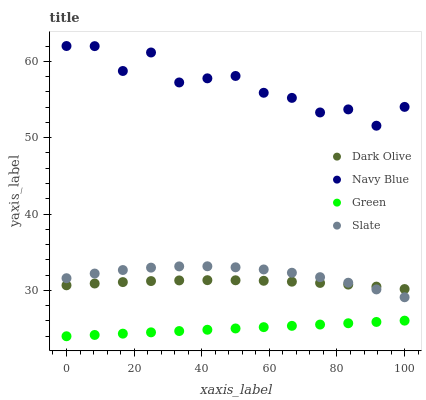Does Green have the minimum area under the curve?
Answer yes or no. Yes. Does Navy Blue have the maximum area under the curve?
Answer yes or no. Yes. Does Slate have the minimum area under the curve?
Answer yes or no. No. Does Slate have the maximum area under the curve?
Answer yes or no. No. Is Green the smoothest?
Answer yes or no. Yes. Is Navy Blue the roughest?
Answer yes or no. Yes. Is Slate the smoothest?
Answer yes or no. No. Is Slate the roughest?
Answer yes or no. No. Does Green have the lowest value?
Answer yes or no. Yes. Does Slate have the lowest value?
Answer yes or no. No. Does Navy Blue have the highest value?
Answer yes or no. Yes. Does Slate have the highest value?
Answer yes or no. No. Is Slate less than Navy Blue?
Answer yes or no. Yes. Is Navy Blue greater than Slate?
Answer yes or no. Yes. Does Slate intersect Dark Olive?
Answer yes or no. Yes. Is Slate less than Dark Olive?
Answer yes or no. No. Is Slate greater than Dark Olive?
Answer yes or no. No. Does Slate intersect Navy Blue?
Answer yes or no. No. 